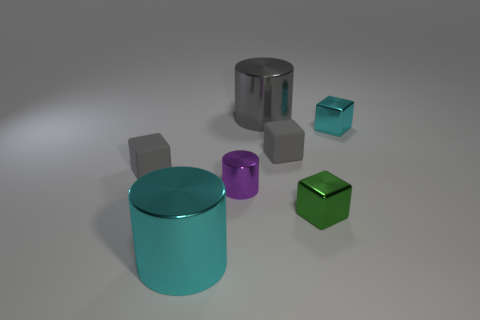Subtract all red cubes. Subtract all yellow cylinders. How many cubes are left? 4 Add 1 small purple metal objects. How many objects exist? 8 Subtract all blocks. How many objects are left? 3 Add 2 small purple metallic objects. How many small purple metallic objects exist? 3 Subtract 0 yellow spheres. How many objects are left? 7 Subtract all tiny green metal cubes. Subtract all cyan cylinders. How many objects are left? 5 Add 3 tiny cylinders. How many tiny cylinders are left? 4 